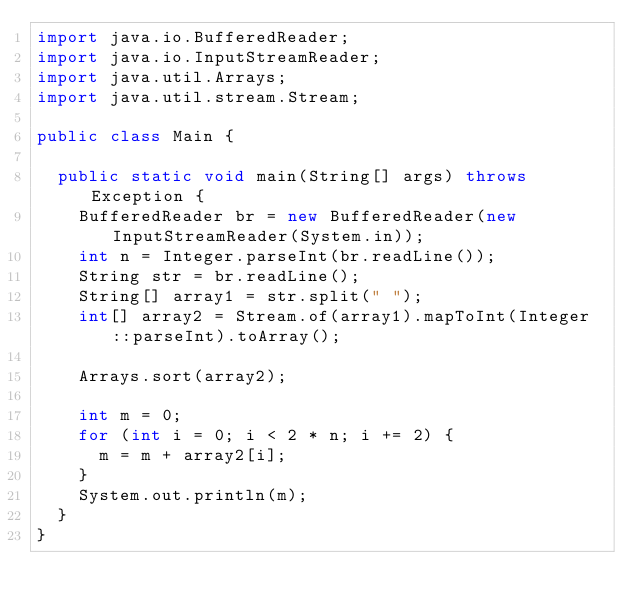<code> <loc_0><loc_0><loc_500><loc_500><_Java_>import java.io.BufferedReader;
import java.io.InputStreamReader;
import java.util.Arrays;
import java.util.stream.Stream;

public class Main {

	public static void main(String[] args) throws Exception {
		BufferedReader br = new BufferedReader(new InputStreamReader(System.in));
		int n = Integer.parseInt(br.readLine());
		String str = br.readLine();
		String[] array1 = str.split(" ");
		int[] array2 = Stream.of(array1).mapToInt(Integer::parseInt).toArray();

		Arrays.sort(array2);

		int m = 0;
		for (int i = 0; i < 2 * n; i += 2) {
			m = m + array2[i];
		}
		System.out.println(m);
	}
}
</code> 